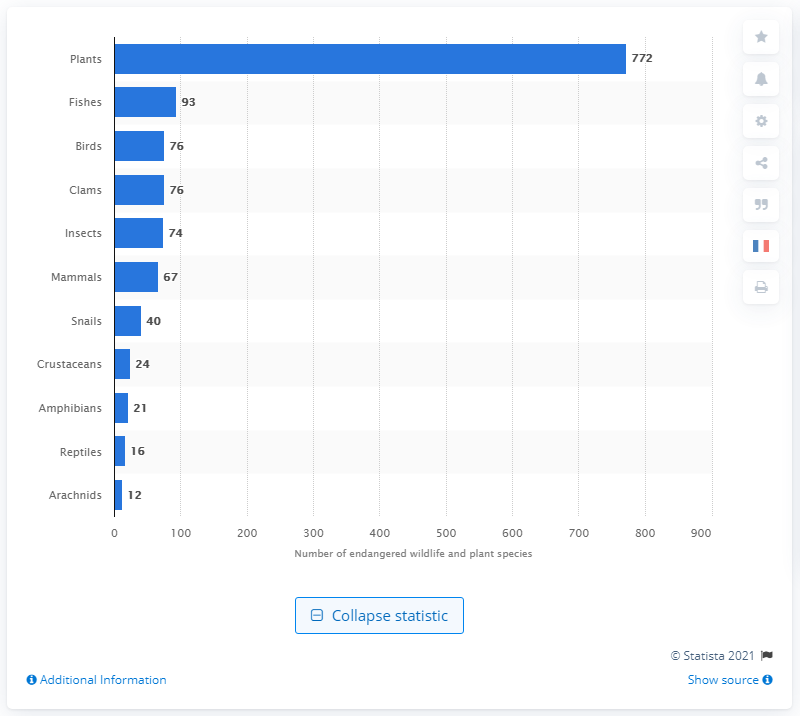Identify some key points in this picture. There are currently 74 insect species that are at risk of becoming extinct due to various factors such as habitat destruction, climate change, and pollution. 